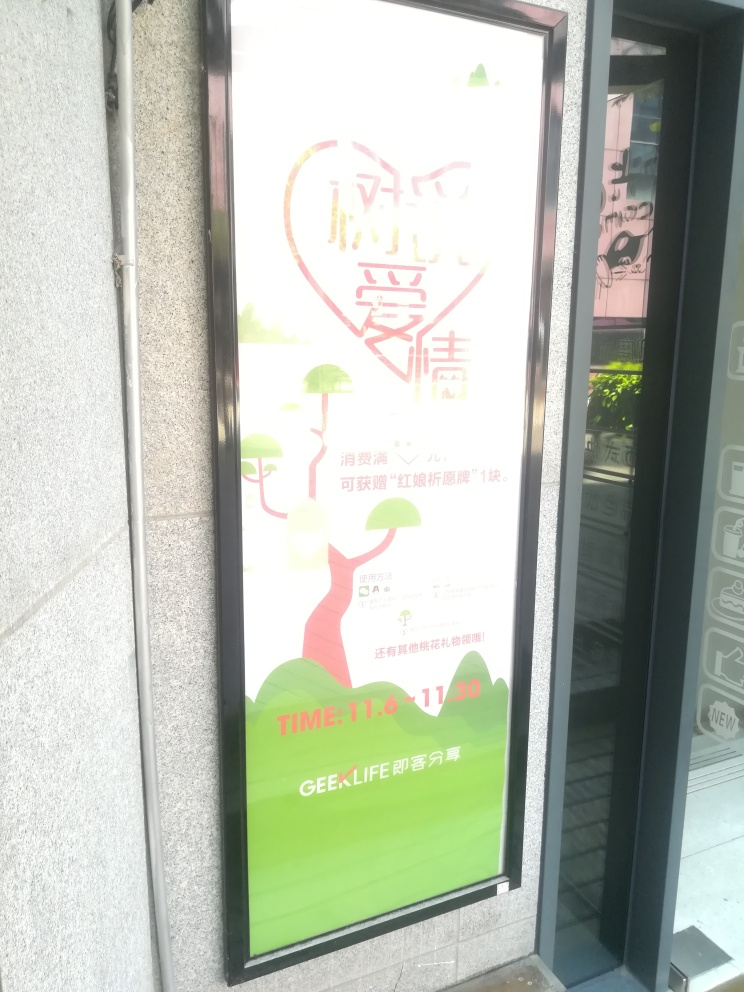How could the design of this advertisement be improved? Improving this design could involve increasing the contrast between the text and the background to enhance legibility, adjusting the lighting to avoid overexposure, and possibly rethinking the color scheme to ensure that all elements are easily discernible. Additionally, making sure the key message and details, such as the date and location for an event, are prominent and readable is essential. 